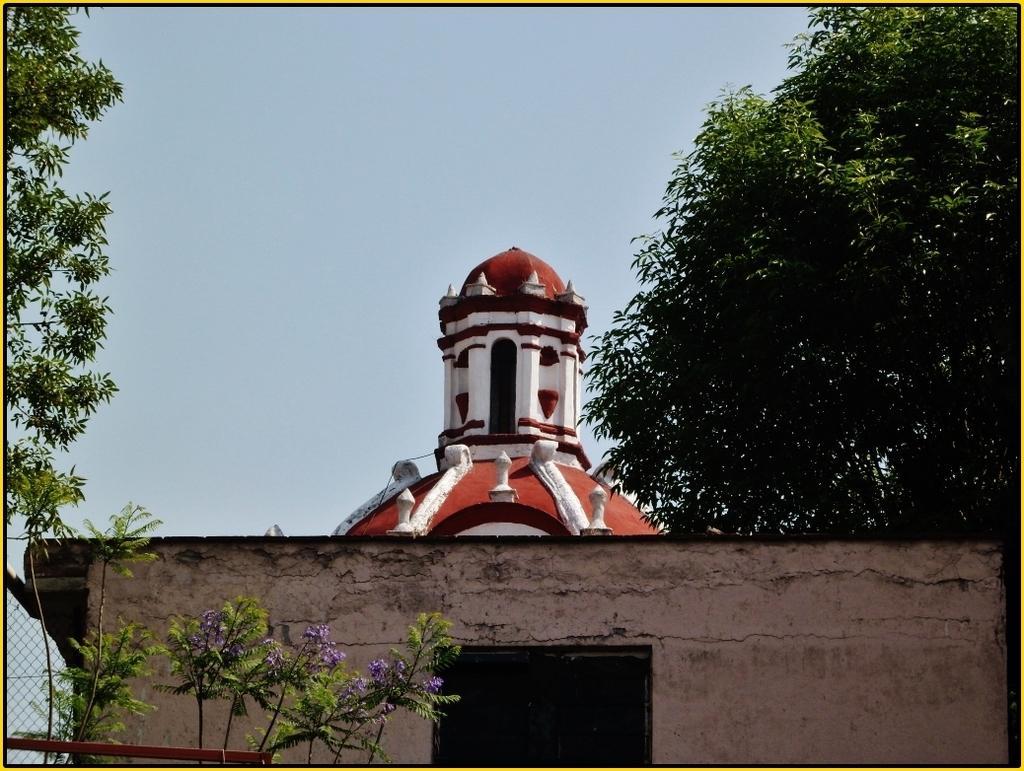Describe this image in one or two sentences. In this image we can see a building. We can also see a metal fence, some trees, flowers and the sky which looks cloudy. 